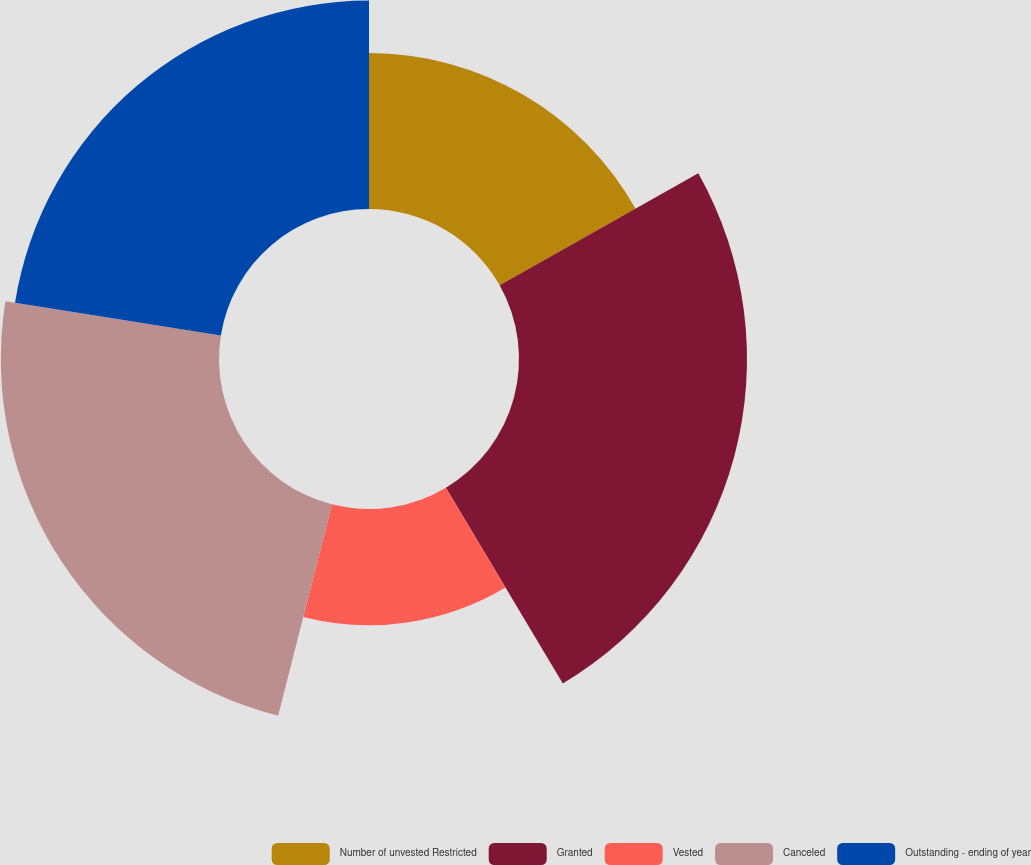<chart> <loc_0><loc_0><loc_500><loc_500><pie_chart><fcel>Number of unvested Restricted<fcel>Granted<fcel>Vested<fcel>Canceled<fcel>Outstanding - ending of year<nl><fcel>16.83%<fcel>24.6%<fcel>12.54%<fcel>23.54%<fcel>22.49%<nl></chart> 